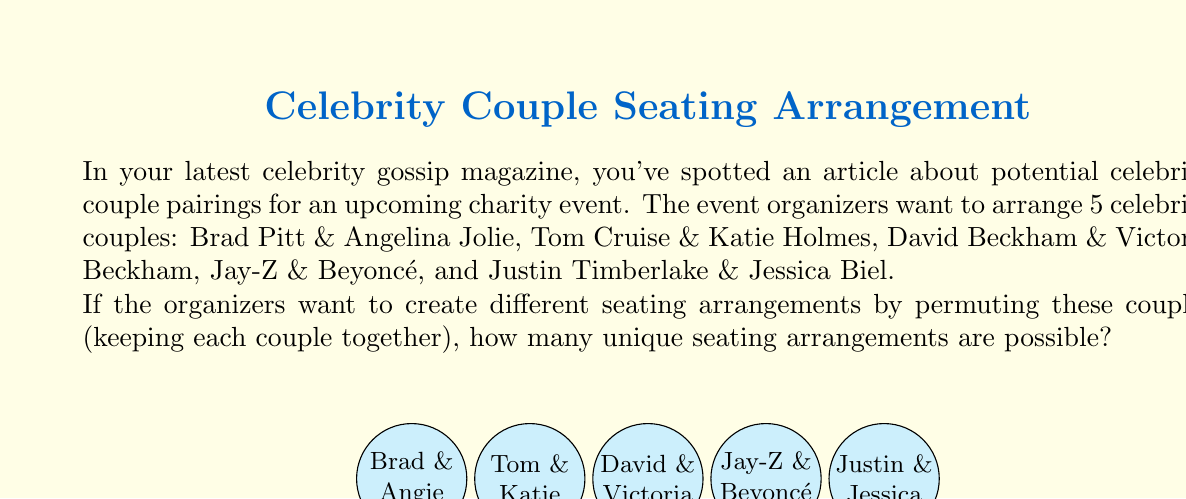Can you answer this question? Let's approach this step-by-step:

1) First, we need to understand what we're calculating. We're looking at permutations of the 5 couples, where each couple stays together as a unit.

2) This is equivalent to finding the number of ways to arrange 5 distinct objects, which is a straightforward permutation.

3) The formula for permutations of $n$ distinct objects is:

   $$P(n) = n!$$

4) In this case, $n = 5$ (for the 5 couples), so we need to calculate:

   $$P(5) = 5!$$

5) Let's expand this:
   
   $$5! = 5 \times 4 \times 3 \times 2 \times 1 = 120$$

6) Therefore, there are 120 possible unique seating arrangements for these 5 celebrity couples.

7) In terms of group theory, this represents the order of the symmetric group $S_5$, which is the group of all permutations on 5 elements.
Answer: $120$ 